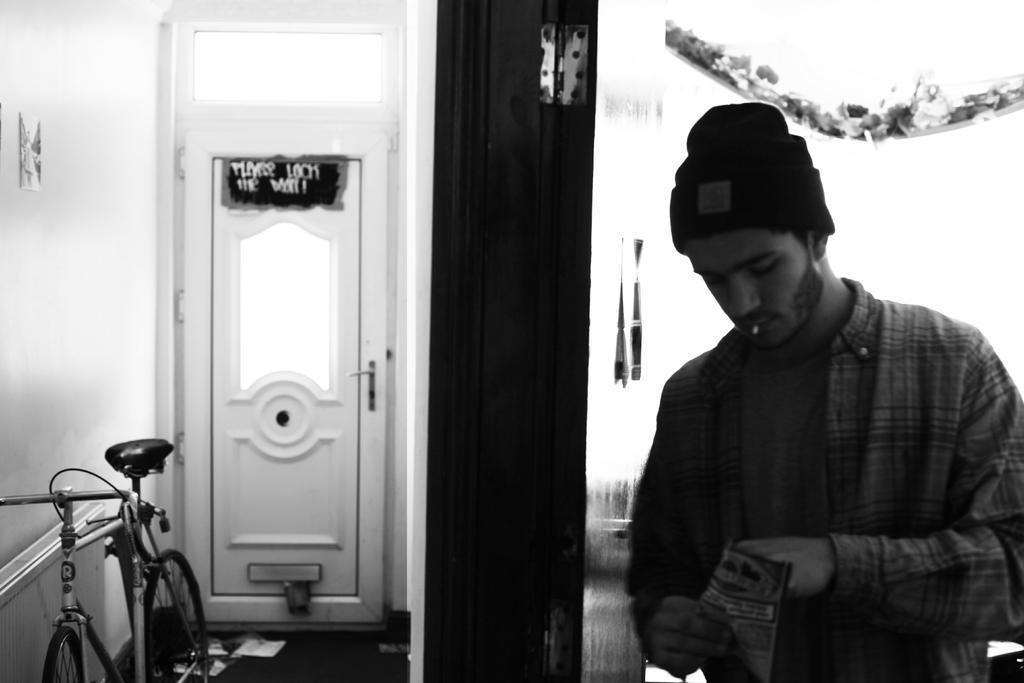Could you give a brief overview of what you see in this image? In this picture we can see a person holding a packet, side we can see door to the wall and we can see bicycle. 